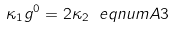<formula> <loc_0><loc_0><loc_500><loc_500>\kappa _ { 1 } g ^ { 0 } = 2 \kappa _ { 2 } \ e q n u m { A 3 }</formula> 